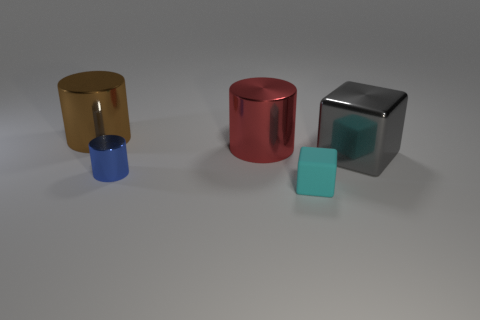Is there anything else that has the same material as the tiny cyan cube?
Keep it short and to the point. No. There is a large gray shiny block; what number of red metal objects are on the left side of it?
Offer a terse response. 1. What number of other objects are there of the same size as the blue thing?
Give a very brief answer. 1. What size is the red object that is the same shape as the brown thing?
Provide a short and direct response. Large. There is a small object that is in front of the tiny blue thing; what is its shape?
Keep it short and to the point. Cube. What color is the cylinder in front of the block that is right of the cyan matte object?
Your answer should be compact. Blue. What number of things are either big things left of the cyan rubber cube or small green matte blocks?
Make the answer very short. 2. Do the matte thing and the blue metallic cylinder that is in front of the big red cylinder have the same size?
Offer a very short reply. Yes. What number of big things are either yellow things or metal things?
Offer a very short reply. 3. What shape is the big gray metal object?
Provide a succinct answer. Cube. 